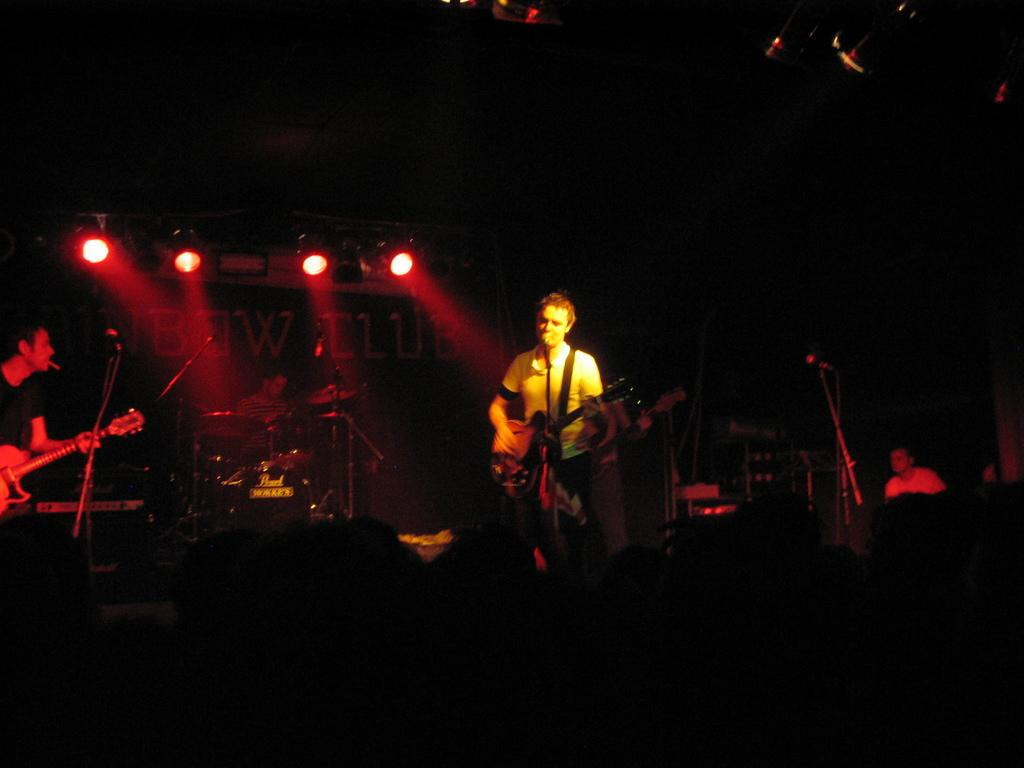What are the people in the image doing? The people in the image are standing and holding guitars. What objects are visible that might be used for amplifying sound? There are microphones visible in the image. What instrument can be seen in the background of the image? In the background, there is a person sitting next to a drum set. What type of screw can be seen holding the guitar strings together in the image? There are no screws visible in the image; the guitar strings are held together by tuning pegs. What game is being played by the people in the image? There is no game being played in the image; the people are holding guitars and may be part of a musical performance. 